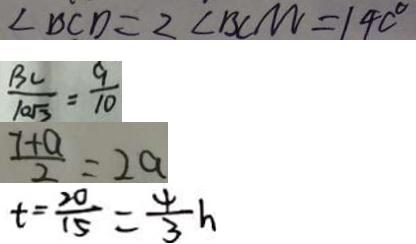Convert formula to latex. <formula><loc_0><loc_0><loc_500><loc_500>\angle B C D = 2 \angle B C M = 1 4 0 ^ { \circ } 
 \frac { B C } { 1 0 \sqrt { 3 } } = \frac { 9 } { 1 0 } 
 \frac { 7 + a } { 2 } = 2 a 
 t = \frac { 2 0 } { 1 5 } = \frac { 4 } { 3 } h</formula> 